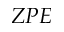<formula> <loc_0><loc_0><loc_500><loc_500>Z P E</formula> 